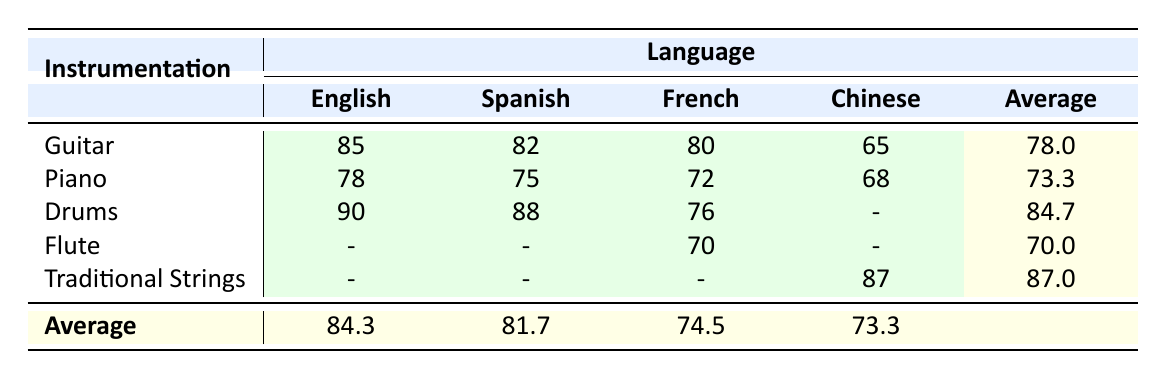What is the Song Recognition Score for the Guitar in Spanish? The table shows that the Song Recognition Score for Guitar in Spanish is 82.
Answer: 82 What is the average Song Recognition Score for the Drums across all languages? The Drums scored 90 in English, 88 in Spanish, and 76 in French. There are no scores for Chinese. To find the average, add the scores: 90 + 88 + 76 = 254, then divide by 3, yielding an average of approximately 84.7.
Answer: 84.7 Is the Song Recognition Score for the Piano higher in English than in French? The table shows that the Piano has a score of 78 in English and 72 in French. Since 78 is greater than 72, the statement is true.
Answer: Yes What is the lowest Song Recognition Score among all the instrumentations listed? In the table, the Guitar in Chinese has the lowest score of 65 compared to the other scores listed.
Answer: 65 Which instrumentation has the highest average Song Recognition Score? To determine this, calculate the average for each instrumentation: Guitar = (85 + 82 + 80 + 65) / 4 = 78.8; Piano = (78 + 75 + 72 + 68) / 4 = 73.3; Drums = (90 + 88 + 76 + NA) / 3 = 84.7; Flute = (70) / 1 = 70; Traditional Strings = (87) / 1 = 87. The highest average is for Traditional Strings with a score of 87.
Answer: Traditional Strings What is the difference in the Song Recognition Score for the Drums between English and Spanish? The Drums score 90 in English and 88 in Spanish. The difference can be calculated as 90 - 88, which equals 2.
Answer: 2 Is there any instrumentation that has a score for every language listed? In the table, Traditional Strings only has a score for Chinese, while the Drums have scores for English, Spanish, and French but not Chinese. All other instrumentation have gaps as well. Therefore, no instrumentation has a score for every language listed.
Answer: No How many instrumentations are there with an average score above 75? The averages so far are Guitar (78.0), Piano (73.3), Drums (84.7), Flute (70.0), and Traditional Strings (87.0). Only Guitar, Drums, and Traditional Strings have an average above 75. Therefore, there are three instrumentations above this threshold.
Answer: 3 Which language has the lowest average Song Recognition Score across all instrumentations? Calculating averages per language: English = (85 + 78 + 90) / 3 = 84.3; Spanish = (82 + 75 + 88) / 3 = 81.7; French = (80 + 72 + 76) / 3 = 74.5; Chinese = (87 + 65 + 68) / 3 = 73.3. The lowest average is for Chinese at 73.3.
Answer: Chinese 